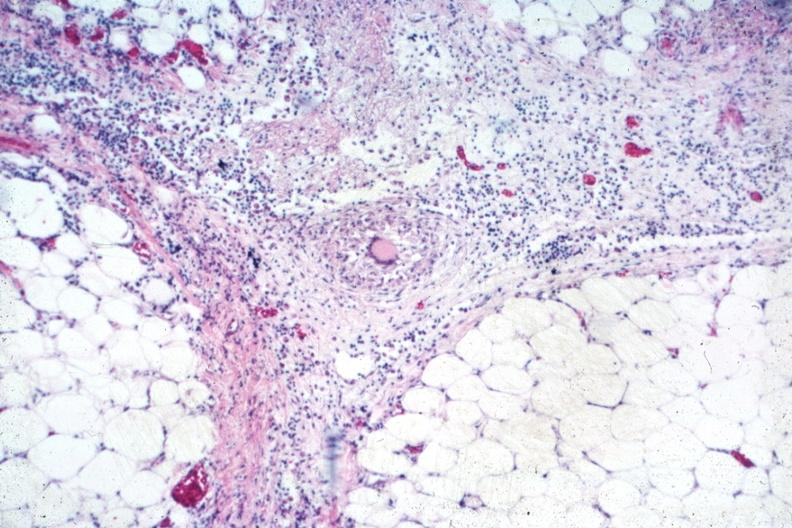s peritoneum present?
Answer the question using a single word or phrase. Yes 